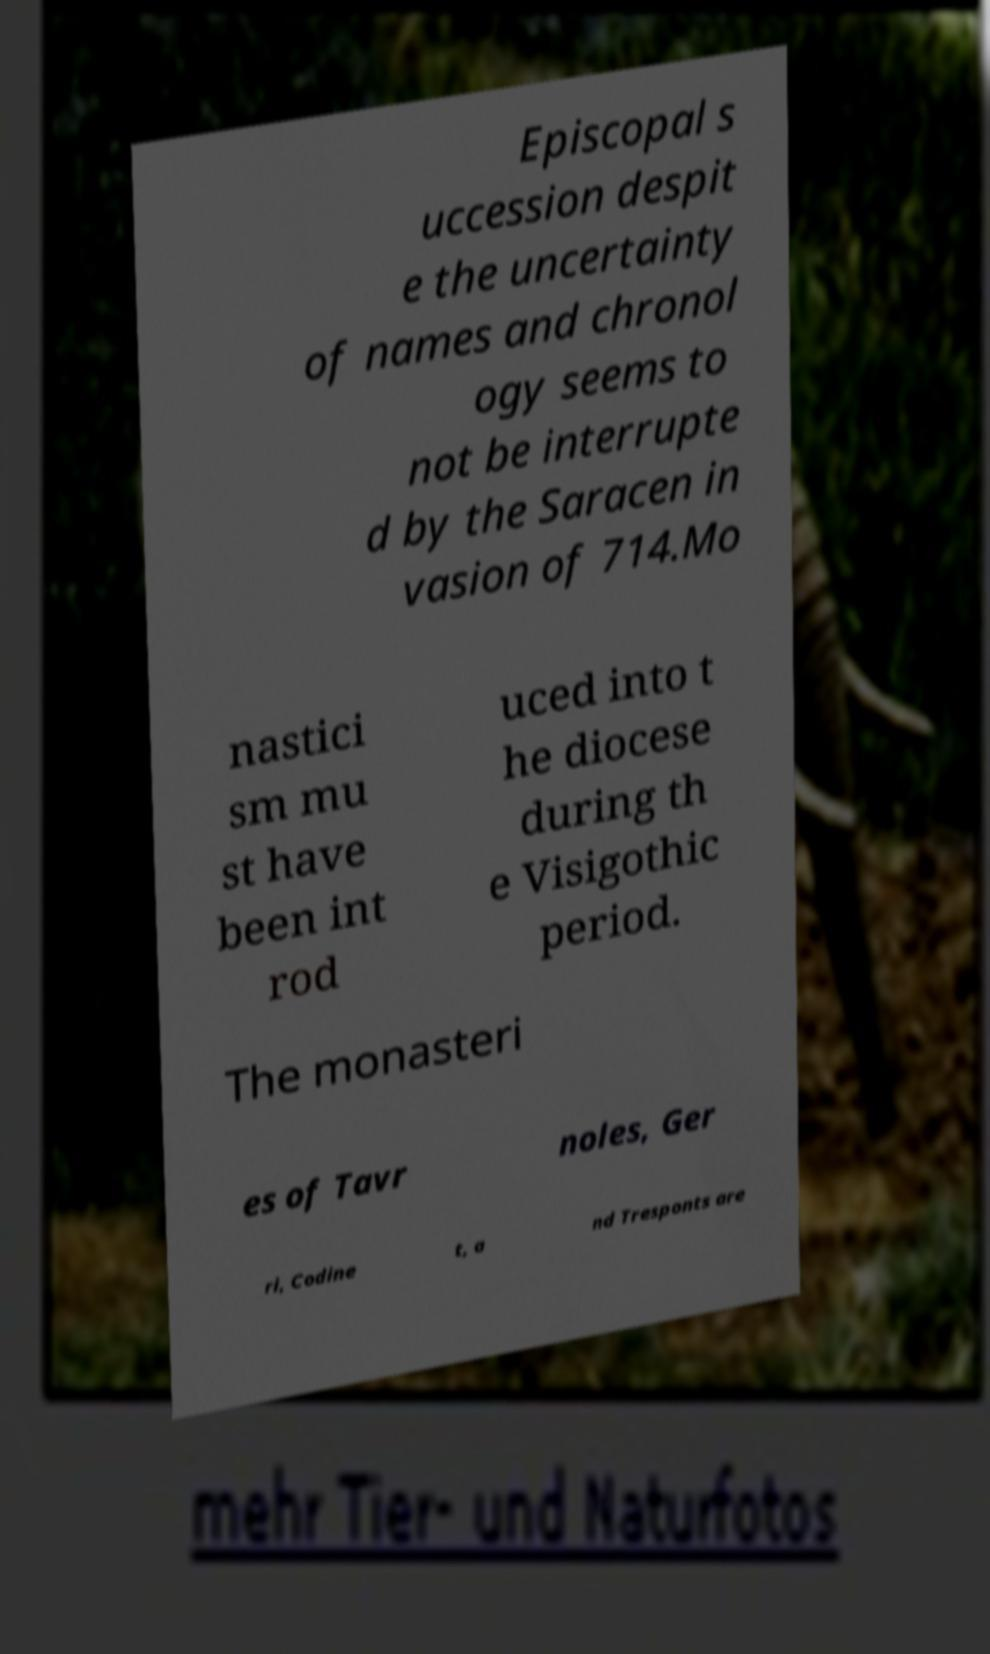There's text embedded in this image that I need extracted. Can you transcribe it verbatim? Episcopal s uccession despit e the uncertainty of names and chronol ogy seems to not be interrupte d by the Saracen in vasion of 714.Mo nastici sm mu st have been int rod uced into t he diocese during th e Visigothic period. The monasteri es of Tavr noles, Ger ri, Codine t, a nd Tresponts are 